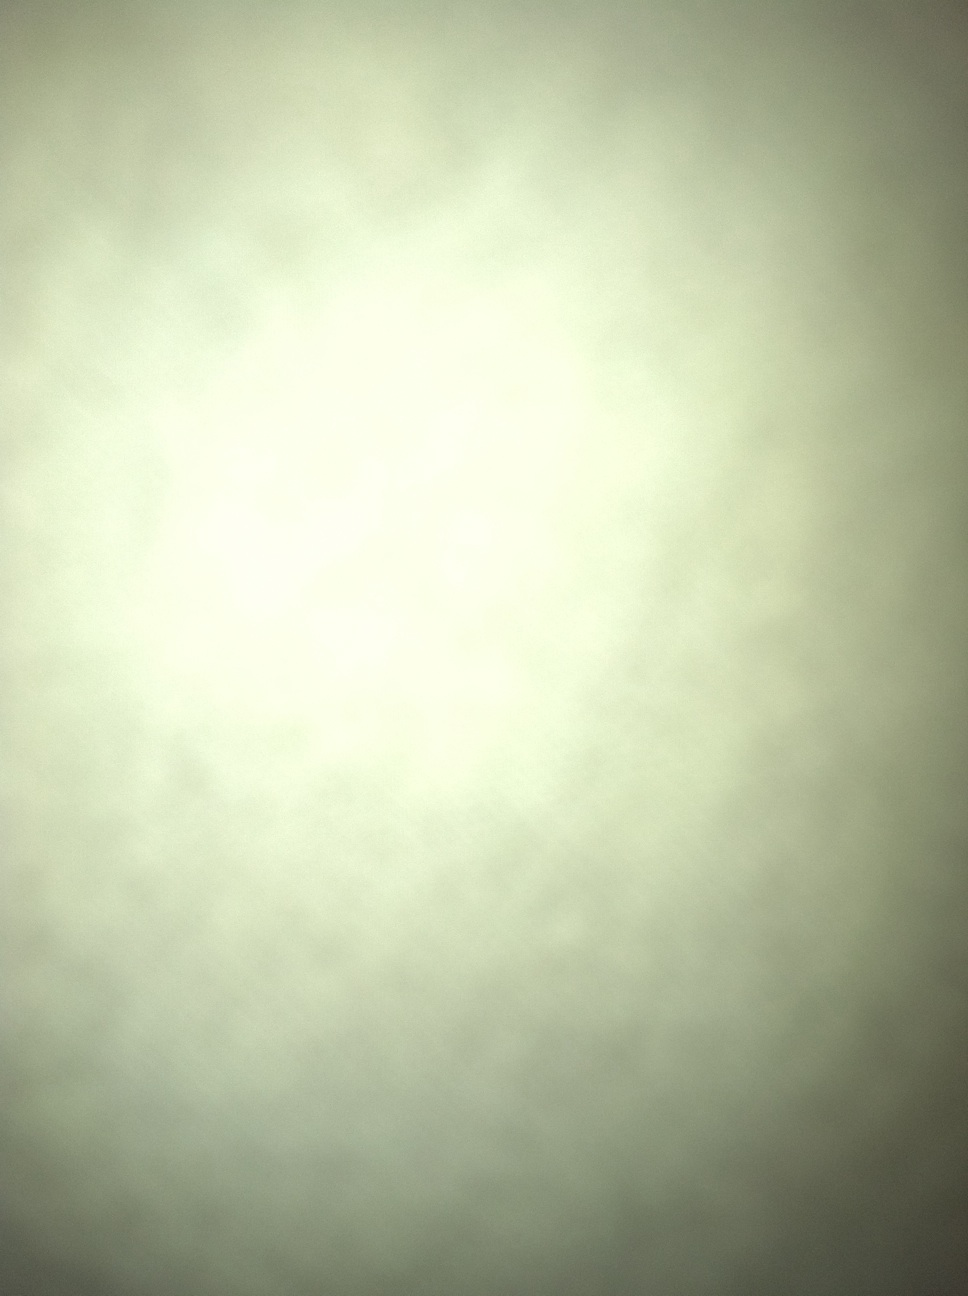What details can you describe from the image provided? The image appears to be unfocused or taken too close to a surface, making it difficult to discern any specific details. It presents a uniform color with a gradient, possibly due to lighting conditions. 